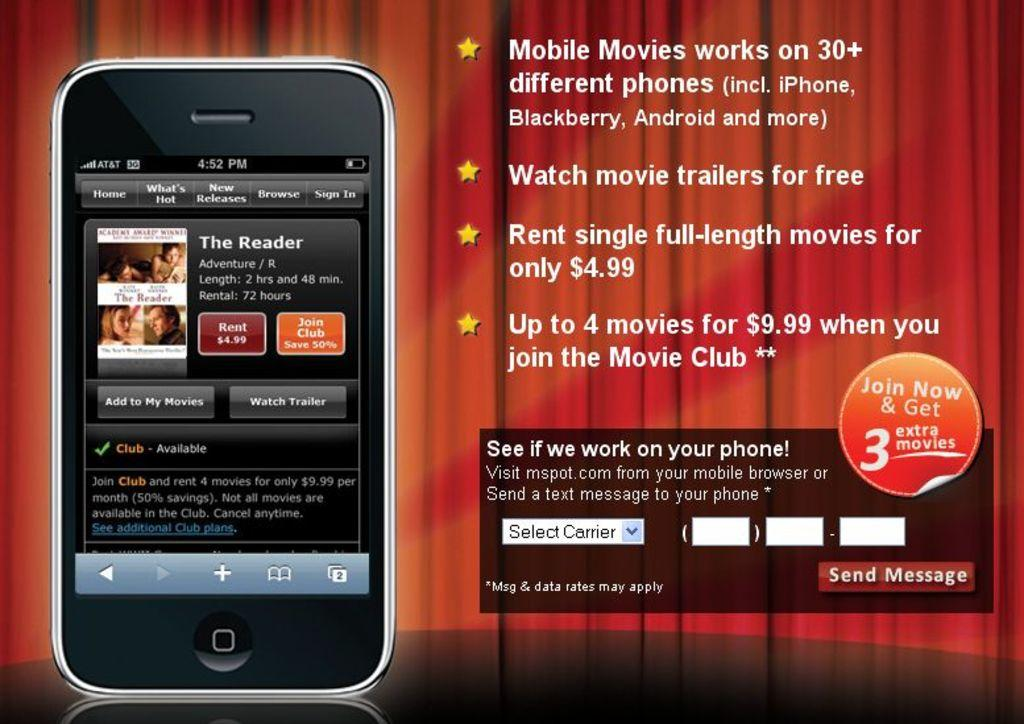<image>
Render a clear and concise summary of the photo. a phone with a watch movie trailers for free button next to it 